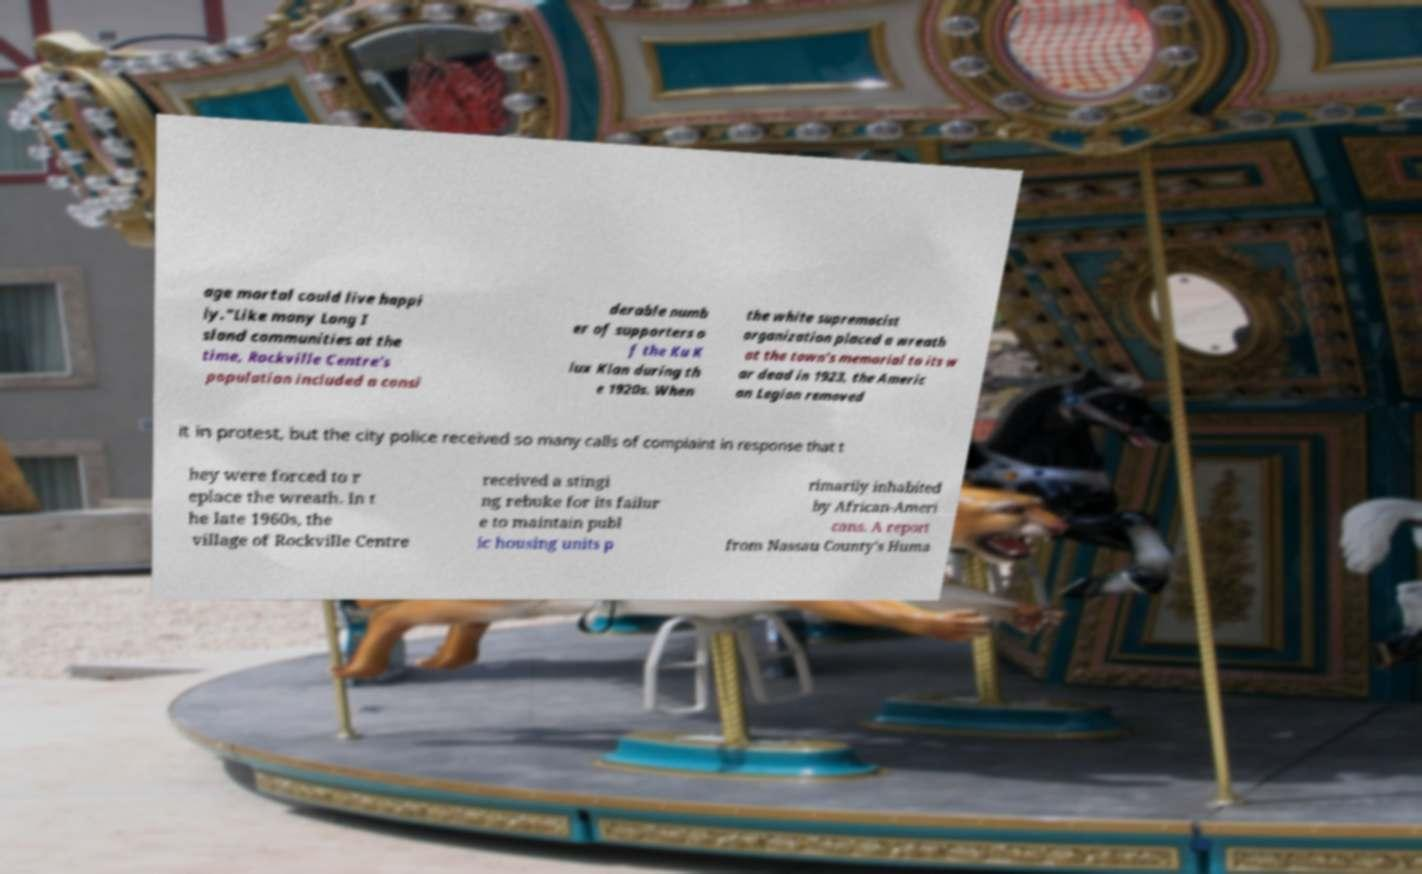Can you accurately transcribe the text from the provided image for me? age mortal could live happi ly."Like many Long I sland communities at the time, Rockville Centre's population included a consi derable numb er of supporters o f the Ku K lux Klan during th e 1920s. When the white supremacist organization placed a wreath at the town's memorial to its w ar dead in 1923, the Americ an Legion removed it in protest, but the city police received so many calls of complaint in response that t hey were forced to r eplace the wreath. In t he late 1960s, the village of Rockville Centre received a stingi ng rebuke for its failur e to maintain publ ic housing units p rimarily inhabited by African-Ameri cans. A report from Nassau County's Huma 